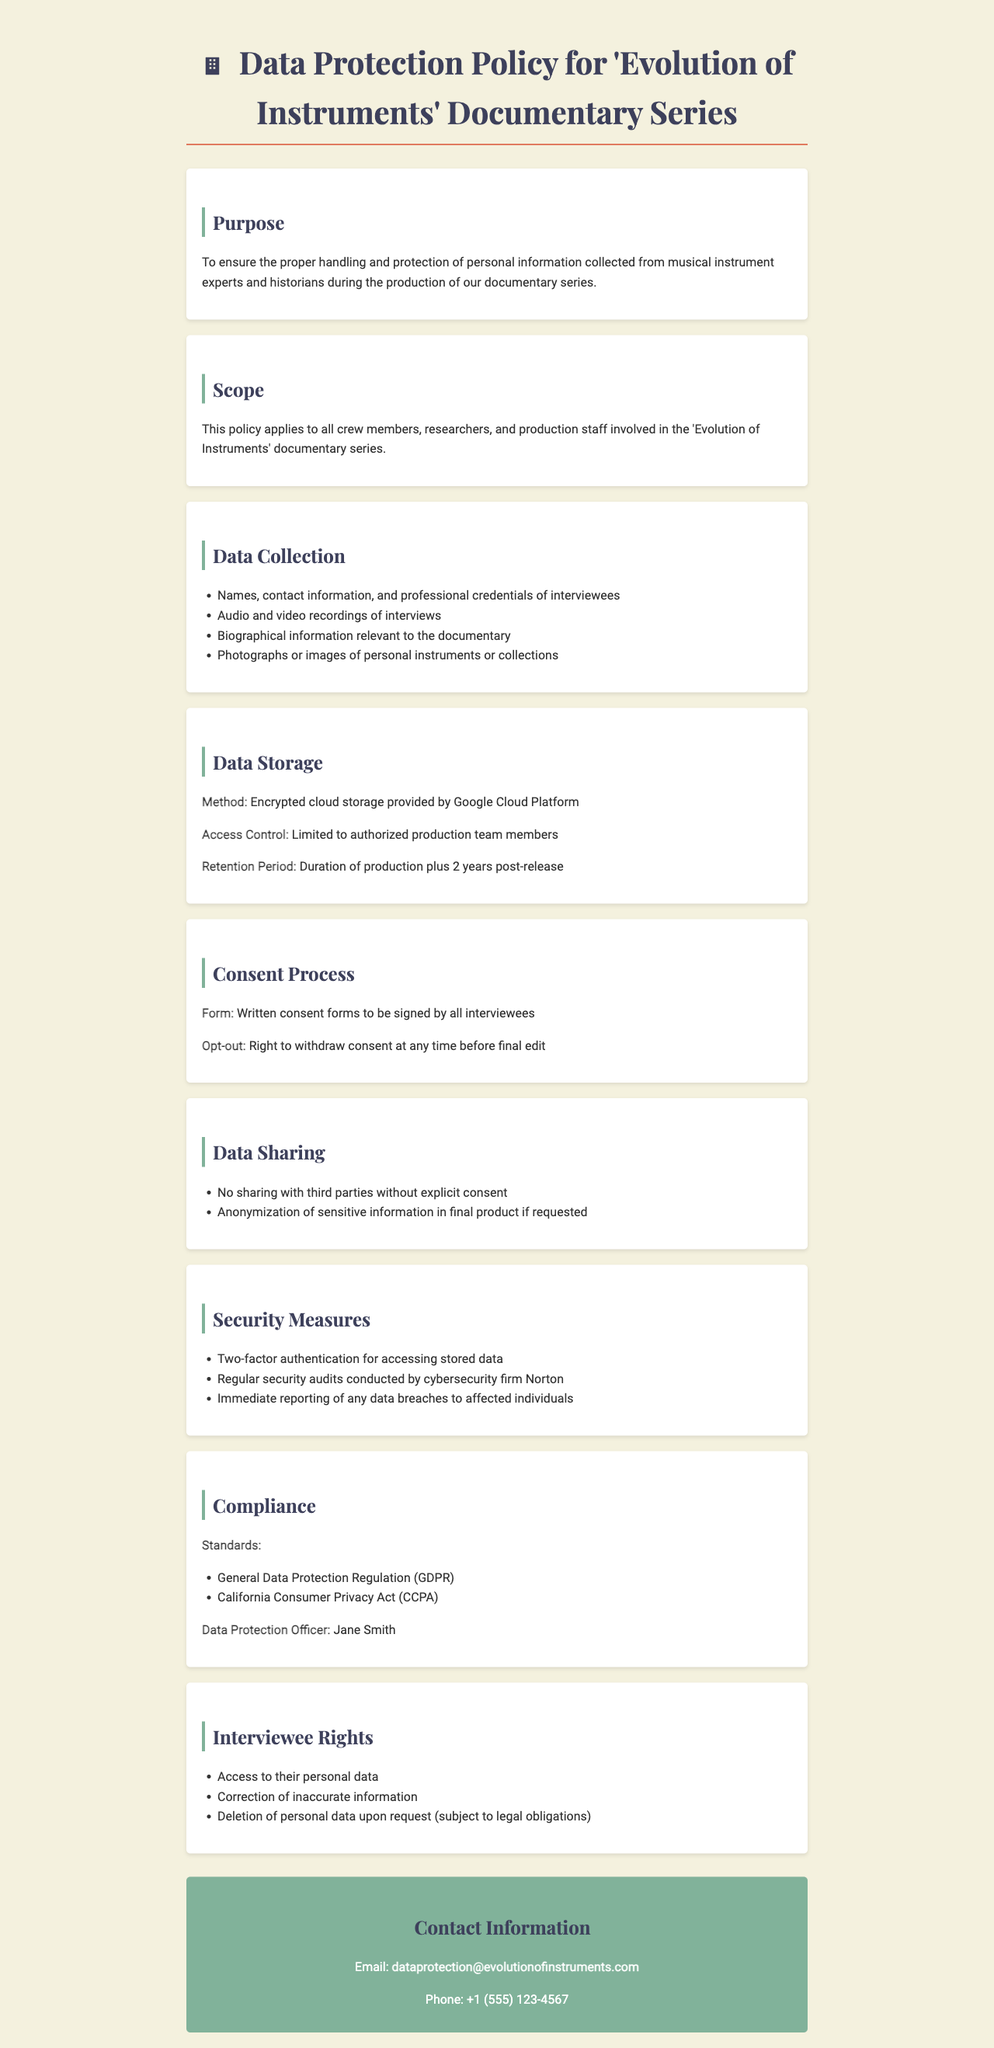What is the title of the document? The title appears at the top of the document and describes the main focus of the content, which is about data protection policy.
Answer: Data Protection Policy for 'Evolution of Instruments' Documentary Series Who is the Data Protection Officer? The document identifies the person responsible for data protection, specifically naming them in the compliance section.
Answer: Jane Smith What is the retention period for stored data? The retention period is mentioned in the data storage section of the document, detailing how long data will be kept.
Answer: Duration of production plus 2 years post-release What kind of consent form is required from interviewees? The consent method is specified in the Consent Process section, indicating the type of consent needed for data handling.
Answer: Written consent forms What security measure is mentioned for accessing stored data? The security measures section lists specific protections in place, including an access requirement for stored data.
Answer: Two-factor authentication Which data protection regulations does the policy comply with? The compliance section outlines the specific legal frameworks that the document adheres to regarding data protection.
Answer: General Data Protection Regulation (GDPR) and California Consumer Privacy Act (CCPA) What should be done in case of a data breach? The document indicates a specific action that must take place if a data breach occurs, located in the security measures section.
Answer: Immediate reporting of any data breaches to affected individuals What rights do interviewees have regarding their personal data? The rights of interviewees are detailed in a dedicated section which outlines what they can do with their information.
Answer: Access to their personal data, Correction of inaccurate information, Deletion of personal data upon request How can individuals contact the data protection team? The contact information section provides methods for reaching out to the team responsible for data protection.
Answer: Email: dataprotection@evolutionofinstruments.com and Phone: +1 (555) 123-4567 